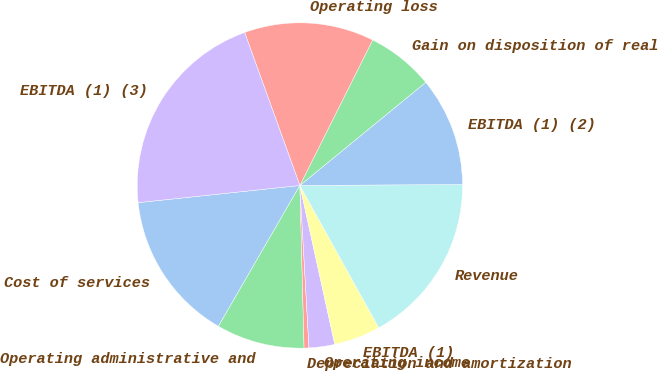<chart> <loc_0><loc_0><loc_500><loc_500><pie_chart><fcel>Cost of services<fcel>Operating administrative and<fcel>Depreciation and amortization<fcel>Operating income<fcel>EBITDA (1)<fcel>Revenue<fcel>EBITDA (1) (2)<fcel>Gain on disposition of real<fcel>Operating loss<fcel>EBITDA (1) (3)<nl><fcel>14.97%<fcel>8.76%<fcel>0.48%<fcel>2.55%<fcel>4.62%<fcel>17.04%<fcel>10.83%<fcel>6.69%<fcel>12.9%<fcel>21.17%<nl></chart> 